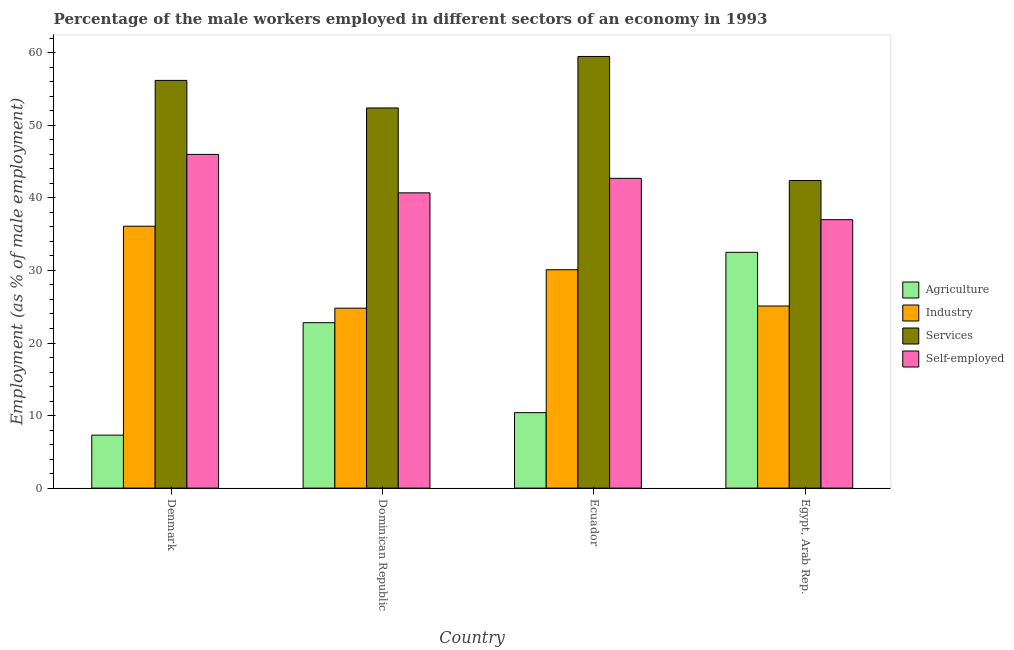Are the number of bars on each tick of the X-axis equal?
Provide a succinct answer. Yes. How many bars are there on the 4th tick from the right?
Offer a very short reply. 4. What is the label of the 1st group of bars from the left?
Make the answer very short. Denmark. In how many cases, is the number of bars for a given country not equal to the number of legend labels?
Offer a very short reply. 0. What is the percentage of male workers in agriculture in Ecuador?
Offer a terse response. 10.4. Across all countries, what is the maximum percentage of male workers in agriculture?
Offer a terse response. 32.5. Across all countries, what is the minimum percentage of male workers in agriculture?
Offer a very short reply. 7.3. In which country was the percentage of male workers in services maximum?
Offer a very short reply. Ecuador. What is the total percentage of self employed male workers in the graph?
Ensure brevity in your answer.  166.4. What is the difference between the percentage of male workers in industry in Denmark and that in Dominican Republic?
Your response must be concise. 11.3. What is the difference between the percentage of self employed male workers in Ecuador and the percentage of male workers in services in Dominican Republic?
Provide a short and direct response. -9.7. What is the average percentage of male workers in agriculture per country?
Provide a succinct answer. 18.25. What is the difference between the percentage of self employed male workers and percentage of male workers in agriculture in Dominican Republic?
Provide a succinct answer. 17.9. What is the ratio of the percentage of male workers in services in Ecuador to that in Egypt, Arab Rep.?
Offer a terse response. 1.4. Is the difference between the percentage of male workers in services in Dominican Republic and Ecuador greater than the difference between the percentage of self employed male workers in Dominican Republic and Ecuador?
Provide a short and direct response. No. What is the difference between the highest and the second highest percentage of male workers in industry?
Offer a very short reply. 6. What is the difference between the highest and the lowest percentage of self employed male workers?
Offer a very short reply. 9. Is the sum of the percentage of male workers in industry in Denmark and Ecuador greater than the maximum percentage of male workers in agriculture across all countries?
Offer a very short reply. Yes. What does the 3rd bar from the left in Denmark represents?
Make the answer very short. Services. What does the 4th bar from the right in Dominican Republic represents?
Keep it short and to the point. Agriculture. Is it the case that in every country, the sum of the percentage of male workers in agriculture and percentage of male workers in industry is greater than the percentage of male workers in services?
Provide a short and direct response. No. Are all the bars in the graph horizontal?
Ensure brevity in your answer.  No. How many countries are there in the graph?
Give a very brief answer. 4. How many legend labels are there?
Provide a short and direct response. 4. What is the title of the graph?
Your answer should be compact. Percentage of the male workers employed in different sectors of an economy in 1993. Does "Switzerland" appear as one of the legend labels in the graph?
Your answer should be very brief. No. What is the label or title of the X-axis?
Keep it short and to the point. Country. What is the label or title of the Y-axis?
Make the answer very short. Employment (as % of male employment). What is the Employment (as % of male employment) of Agriculture in Denmark?
Provide a short and direct response. 7.3. What is the Employment (as % of male employment) in Industry in Denmark?
Provide a short and direct response. 36.1. What is the Employment (as % of male employment) of Services in Denmark?
Keep it short and to the point. 56.2. What is the Employment (as % of male employment) in Self-employed in Denmark?
Your answer should be very brief. 46. What is the Employment (as % of male employment) in Agriculture in Dominican Republic?
Offer a very short reply. 22.8. What is the Employment (as % of male employment) of Industry in Dominican Republic?
Ensure brevity in your answer.  24.8. What is the Employment (as % of male employment) in Services in Dominican Republic?
Offer a terse response. 52.4. What is the Employment (as % of male employment) of Self-employed in Dominican Republic?
Make the answer very short. 40.7. What is the Employment (as % of male employment) in Agriculture in Ecuador?
Make the answer very short. 10.4. What is the Employment (as % of male employment) of Industry in Ecuador?
Your answer should be very brief. 30.1. What is the Employment (as % of male employment) in Services in Ecuador?
Your response must be concise. 59.5. What is the Employment (as % of male employment) in Self-employed in Ecuador?
Offer a terse response. 42.7. What is the Employment (as % of male employment) in Agriculture in Egypt, Arab Rep.?
Give a very brief answer. 32.5. What is the Employment (as % of male employment) of Industry in Egypt, Arab Rep.?
Offer a very short reply. 25.1. What is the Employment (as % of male employment) of Services in Egypt, Arab Rep.?
Keep it short and to the point. 42.4. Across all countries, what is the maximum Employment (as % of male employment) of Agriculture?
Your response must be concise. 32.5. Across all countries, what is the maximum Employment (as % of male employment) in Industry?
Ensure brevity in your answer.  36.1. Across all countries, what is the maximum Employment (as % of male employment) of Services?
Offer a very short reply. 59.5. Across all countries, what is the maximum Employment (as % of male employment) in Self-employed?
Give a very brief answer. 46. Across all countries, what is the minimum Employment (as % of male employment) in Agriculture?
Give a very brief answer. 7.3. Across all countries, what is the minimum Employment (as % of male employment) of Industry?
Offer a very short reply. 24.8. Across all countries, what is the minimum Employment (as % of male employment) of Services?
Offer a very short reply. 42.4. Across all countries, what is the minimum Employment (as % of male employment) in Self-employed?
Make the answer very short. 37. What is the total Employment (as % of male employment) in Agriculture in the graph?
Provide a short and direct response. 73. What is the total Employment (as % of male employment) in Industry in the graph?
Offer a terse response. 116.1. What is the total Employment (as % of male employment) of Services in the graph?
Your answer should be compact. 210.5. What is the total Employment (as % of male employment) in Self-employed in the graph?
Ensure brevity in your answer.  166.4. What is the difference between the Employment (as % of male employment) in Agriculture in Denmark and that in Dominican Republic?
Offer a terse response. -15.5. What is the difference between the Employment (as % of male employment) of Agriculture in Denmark and that in Ecuador?
Provide a succinct answer. -3.1. What is the difference between the Employment (as % of male employment) of Industry in Denmark and that in Ecuador?
Your answer should be very brief. 6. What is the difference between the Employment (as % of male employment) in Self-employed in Denmark and that in Ecuador?
Ensure brevity in your answer.  3.3. What is the difference between the Employment (as % of male employment) of Agriculture in Denmark and that in Egypt, Arab Rep.?
Ensure brevity in your answer.  -25.2. What is the difference between the Employment (as % of male employment) of Industry in Denmark and that in Egypt, Arab Rep.?
Ensure brevity in your answer.  11. What is the difference between the Employment (as % of male employment) of Self-employed in Denmark and that in Egypt, Arab Rep.?
Your response must be concise. 9. What is the difference between the Employment (as % of male employment) of Agriculture in Dominican Republic and that in Ecuador?
Your answer should be compact. 12.4. What is the difference between the Employment (as % of male employment) of Industry in Dominican Republic and that in Ecuador?
Provide a short and direct response. -5.3. What is the difference between the Employment (as % of male employment) of Self-employed in Dominican Republic and that in Ecuador?
Give a very brief answer. -2. What is the difference between the Employment (as % of male employment) in Agriculture in Dominican Republic and that in Egypt, Arab Rep.?
Make the answer very short. -9.7. What is the difference between the Employment (as % of male employment) of Self-employed in Dominican Republic and that in Egypt, Arab Rep.?
Make the answer very short. 3.7. What is the difference between the Employment (as % of male employment) in Agriculture in Ecuador and that in Egypt, Arab Rep.?
Offer a terse response. -22.1. What is the difference between the Employment (as % of male employment) of Industry in Ecuador and that in Egypt, Arab Rep.?
Provide a short and direct response. 5. What is the difference between the Employment (as % of male employment) in Services in Ecuador and that in Egypt, Arab Rep.?
Your answer should be very brief. 17.1. What is the difference between the Employment (as % of male employment) in Self-employed in Ecuador and that in Egypt, Arab Rep.?
Keep it short and to the point. 5.7. What is the difference between the Employment (as % of male employment) in Agriculture in Denmark and the Employment (as % of male employment) in Industry in Dominican Republic?
Offer a terse response. -17.5. What is the difference between the Employment (as % of male employment) in Agriculture in Denmark and the Employment (as % of male employment) in Services in Dominican Republic?
Your response must be concise. -45.1. What is the difference between the Employment (as % of male employment) in Agriculture in Denmark and the Employment (as % of male employment) in Self-employed in Dominican Republic?
Offer a terse response. -33.4. What is the difference between the Employment (as % of male employment) in Industry in Denmark and the Employment (as % of male employment) in Services in Dominican Republic?
Make the answer very short. -16.3. What is the difference between the Employment (as % of male employment) in Industry in Denmark and the Employment (as % of male employment) in Self-employed in Dominican Republic?
Your answer should be very brief. -4.6. What is the difference between the Employment (as % of male employment) of Services in Denmark and the Employment (as % of male employment) of Self-employed in Dominican Republic?
Your answer should be very brief. 15.5. What is the difference between the Employment (as % of male employment) of Agriculture in Denmark and the Employment (as % of male employment) of Industry in Ecuador?
Provide a succinct answer. -22.8. What is the difference between the Employment (as % of male employment) in Agriculture in Denmark and the Employment (as % of male employment) in Services in Ecuador?
Provide a short and direct response. -52.2. What is the difference between the Employment (as % of male employment) in Agriculture in Denmark and the Employment (as % of male employment) in Self-employed in Ecuador?
Provide a short and direct response. -35.4. What is the difference between the Employment (as % of male employment) in Industry in Denmark and the Employment (as % of male employment) in Services in Ecuador?
Ensure brevity in your answer.  -23.4. What is the difference between the Employment (as % of male employment) of Industry in Denmark and the Employment (as % of male employment) of Self-employed in Ecuador?
Provide a succinct answer. -6.6. What is the difference between the Employment (as % of male employment) of Agriculture in Denmark and the Employment (as % of male employment) of Industry in Egypt, Arab Rep.?
Give a very brief answer. -17.8. What is the difference between the Employment (as % of male employment) in Agriculture in Denmark and the Employment (as % of male employment) in Services in Egypt, Arab Rep.?
Make the answer very short. -35.1. What is the difference between the Employment (as % of male employment) of Agriculture in Denmark and the Employment (as % of male employment) of Self-employed in Egypt, Arab Rep.?
Provide a short and direct response. -29.7. What is the difference between the Employment (as % of male employment) in Industry in Denmark and the Employment (as % of male employment) in Services in Egypt, Arab Rep.?
Ensure brevity in your answer.  -6.3. What is the difference between the Employment (as % of male employment) of Industry in Denmark and the Employment (as % of male employment) of Self-employed in Egypt, Arab Rep.?
Give a very brief answer. -0.9. What is the difference between the Employment (as % of male employment) of Services in Denmark and the Employment (as % of male employment) of Self-employed in Egypt, Arab Rep.?
Offer a very short reply. 19.2. What is the difference between the Employment (as % of male employment) in Agriculture in Dominican Republic and the Employment (as % of male employment) in Services in Ecuador?
Ensure brevity in your answer.  -36.7. What is the difference between the Employment (as % of male employment) of Agriculture in Dominican Republic and the Employment (as % of male employment) of Self-employed in Ecuador?
Your answer should be compact. -19.9. What is the difference between the Employment (as % of male employment) of Industry in Dominican Republic and the Employment (as % of male employment) of Services in Ecuador?
Offer a terse response. -34.7. What is the difference between the Employment (as % of male employment) of Industry in Dominican Republic and the Employment (as % of male employment) of Self-employed in Ecuador?
Ensure brevity in your answer.  -17.9. What is the difference between the Employment (as % of male employment) of Agriculture in Dominican Republic and the Employment (as % of male employment) of Services in Egypt, Arab Rep.?
Provide a succinct answer. -19.6. What is the difference between the Employment (as % of male employment) in Industry in Dominican Republic and the Employment (as % of male employment) in Services in Egypt, Arab Rep.?
Your answer should be very brief. -17.6. What is the difference between the Employment (as % of male employment) of Industry in Dominican Republic and the Employment (as % of male employment) of Self-employed in Egypt, Arab Rep.?
Provide a short and direct response. -12.2. What is the difference between the Employment (as % of male employment) of Agriculture in Ecuador and the Employment (as % of male employment) of Industry in Egypt, Arab Rep.?
Your response must be concise. -14.7. What is the difference between the Employment (as % of male employment) of Agriculture in Ecuador and the Employment (as % of male employment) of Services in Egypt, Arab Rep.?
Your answer should be very brief. -32. What is the difference between the Employment (as % of male employment) in Agriculture in Ecuador and the Employment (as % of male employment) in Self-employed in Egypt, Arab Rep.?
Offer a very short reply. -26.6. What is the difference between the Employment (as % of male employment) in Industry in Ecuador and the Employment (as % of male employment) in Services in Egypt, Arab Rep.?
Offer a very short reply. -12.3. What is the difference between the Employment (as % of male employment) in Industry in Ecuador and the Employment (as % of male employment) in Self-employed in Egypt, Arab Rep.?
Provide a succinct answer. -6.9. What is the difference between the Employment (as % of male employment) of Services in Ecuador and the Employment (as % of male employment) of Self-employed in Egypt, Arab Rep.?
Keep it short and to the point. 22.5. What is the average Employment (as % of male employment) of Agriculture per country?
Offer a very short reply. 18.25. What is the average Employment (as % of male employment) of Industry per country?
Offer a terse response. 29.02. What is the average Employment (as % of male employment) in Services per country?
Offer a very short reply. 52.62. What is the average Employment (as % of male employment) of Self-employed per country?
Provide a succinct answer. 41.6. What is the difference between the Employment (as % of male employment) of Agriculture and Employment (as % of male employment) of Industry in Denmark?
Your answer should be compact. -28.8. What is the difference between the Employment (as % of male employment) of Agriculture and Employment (as % of male employment) of Services in Denmark?
Provide a succinct answer. -48.9. What is the difference between the Employment (as % of male employment) of Agriculture and Employment (as % of male employment) of Self-employed in Denmark?
Your response must be concise. -38.7. What is the difference between the Employment (as % of male employment) of Industry and Employment (as % of male employment) of Services in Denmark?
Provide a short and direct response. -20.1. What is the difference between the Employment (as % of male employment) in Industry and Employment (as % of male employment) in Self-employed in Denmark?
Keep it short and to the point. -9.9. What is the difference between the Employment (as % of male employment) in Agriculture and Employment (as % of male employment) in Industry in Dominican Republic?
Offer a terse response. -2. What is the difference between the Employment (as % of male employment) of Agriculture and Employment (as % of male employment) of Services in Dominican Republic?
Your response must be concise. -29.6. What is the difference between the Employment (as % of male employment) of Agriculture and Employment (as % of male employment) of Self-employed in Dominican Republic?
Give a very brief answer. -17.9. What is the difference between the Employment (as % of male employment) in Industry and Employment (as % of male employment) in Services in Dominican Republic?
Ensure brevity in your answer.  -27.6. What is the difference between the Employment (as % of male employment) of Industry and Employment (as % of male employment) of Self-employed in Dominican Republic?
Your response must be concise. -15.9. What is the difference between the Employment (as % of male employment) in Agriculture and Employment (as % of male employment) in Industry in Ecuador?
Your response must be concise. -19.7. What is the difference between the Employment (as % of male employment) of Agriculture and Employment (as % of male employment) of Services in Ecuador?
Provide a succinct answer. -49.1. What is the difference between the Employment (as % of male employment) in Agriculture and Employment (as % of male employment) in Self-employed in Ecuador?
Your answer should be compact. -32.3. What is the difference between the Employment (as % of male employment) in Industry and Employment (as % of male employment) in Services in Ecuador?
Provide a short and direct response. -29.4. What is the difference between the Employment (as % of male employment) in Industry and Employment (as % of male employment) in Self-employed in Ecuador?
Keep it short and to the point. -12.6. What is the difference between the Employment (as % of male employment) of Industry and Employment (as % of male employment) of Services in Egypt, Arab Rep.?
Your answer should be very brief. -17.3. What is the difference between the Employment (as % of male employment) of Industry and Employment (as % of male employment) of Self-employed in Egypt, Arab Rep.?
Give a very brief answer. -11.9. What is the difference between the Employment (as % of male employment) in Services and Employment (as % of male employment) in Self-employed in Egypt, Arab Rep.?
Your answer should be very brief. 5.4. What is the ratio of the Employment (as % of male employment) in Agriculture in Denmark to that in Dominican Republic?
Your answer should be very brief. 0.32. What is the ratio of the Employment (as % of male employment) of Industry in Denmark to that in Dominican Republic?
Your answer should be very brief. 1.46. What is the ratio of the Employment (as % of male employment) in Services in Denmark to that in Dominican Republic?
Offer a very short reply. 1.07. What is the ratio of the Employment (as % of male employment) in Self-employed in Denmark to that in Dominican Republic?
Offer a very short reply. 1.13. What is the ratio of the Employment (as % of male employment) in Agriculture in Denmark to that in Ecuador?
Your answer should be very brief. 0.7. What is the ratio of the Employment (as % of male employment) of Industry in Denmark to that in Ecuador?
Your answer should be compact. 1.2. What is the ratio of the Employment (as % of male employment) in Services in Denmark to that in Ecuador?
Offer a very short reply. 0.94. What is the ratio of the Employment (as % of male employment) in Self-employed in Denmark to that in Ecuador?
Your answer should be compact. 1.08. What is the ratio of the Employment (as % of male employment) of Agriculture in Denmark to that in Egypt, Arab Rep.?
Ensure brevity in your answer.  0.22. What is the ratio of the Employment (as % of male employment) of Industry in Denmark to that in Egypt, Arab Rep.?
Offer a very short reply. 1.44. What is the ratio of the Employment (as % of male employment) of Services in Denmark to that in Egypt, Arab Rep.?
Give a very brief answer. 1.33. What is the ratio of the Employment (as % of male employment) of Self-employed in Denmark to that in Egypt, Arab Rep.?
Offer a very short reply. 1.24. What is the ratio of the Employment (as % of male employment) in Agriculture in Dominican Republic to that in Ecuador?
Offer a very short reply. 2.19. What is the ratio of the Employment (as % of male employment) in Industry in Dominican Republic to that in Ecuador?
Make the answer very short. 0.82. What is the ratio of the Employment (as % of male employment) of Services in Dominican Republic to that in Ecuador?
Offer a terse response. 0.88. What is the ratio of the Employment (as % of male employment) in Self-employed in Dominican Republic to that in Ecuador?
Your response must be concise. 0.95. What is the ratio of the Employment (as % of male employment) in Agriculture in Dominican Republic to that in Egypt, Arab Rep.?
Keep it short and to the point. 0.7. What is the ratio of the Employment (as % of male employment) of Services in Dominican Republic to that in Egypt, Arab Rep.?
Offer a terse response. 1.24. What is the ratio of the Employment (as % of male employment) in Self-employed in Dominican Republic to that in Egypt, Arab Rep.?
Keep it short and to the point. 1.1. What is the ratio of the Employment (as % of male employment) in Agriculture in Ecuador to that in Egypt, Arab Rep.?
Provide a succinct answer. 0.32. What is the ratio of the Employment (as % of male employment) in Industry in Ecuador to that in Egypt, Arab Rep.?
Provide a succinct answer. 1.2. What is the ratio of the Employment (as % of male employment) of Services in Ecuador to that in Egypt, Arab Rep.?
Provide a short and direct response. 1.4. What is the ratio of the Employment (as % of male employment) in Self-employed in Ecuador to that in Egypt, Arab Rep.?
Keep it short and to the point. 1.15. What is the difference between the highest and the second highest Employment (as % of male employment) of Self-employed?
Offer a very short reply. 3.3. What is the difference between the highest and the lowest Employment (as % of male employment) in Agriculture?
Keep it short and to the point. 25.2. What is the difference between the highest and the lowest Employment (as % of male employment) of Services?
Offer a terse response. 17.1. 